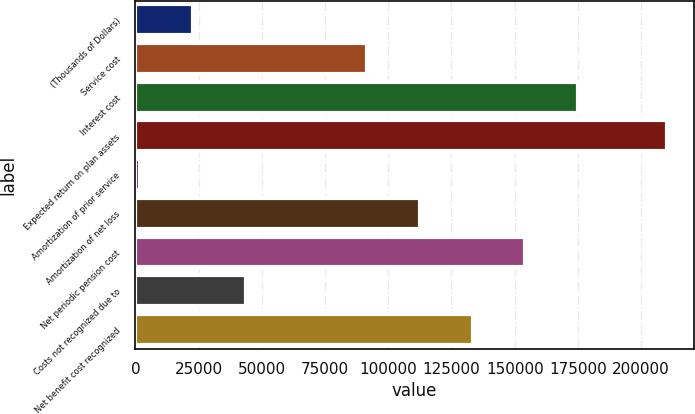Convert chart to OTSL. <chart><loc_0><loc_0><loc_500><loc_500><bar_chart><fcel>(Thousands of Dollars)<fcel>Service cost<fcel>Interest cost<fcel>Expected return on plan assets<fcel>Amortization of prior service<fcel>Amortization of net loss<fcel>Net periodic pension cost<fcel>Costs not recognized due to<fcel>Net benefit cost recognized<nl><fcel>22757<fcel>91739<fcel>175091<fcel>210299<fcel>1919<fcel>112577<fcel>154253<fcel>43595<fcel>133415<nl></chart> 